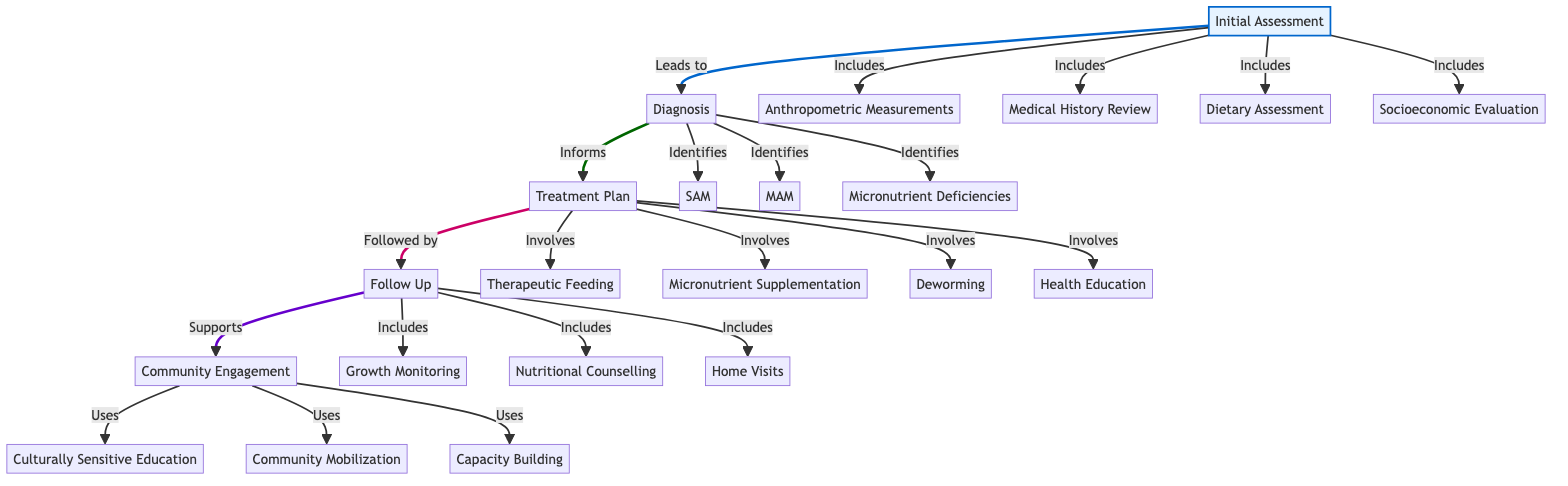What are the components of the Initial Assessment? The diagram lists four components under Initial Assessment: Anthropometric Measurements, Medical History Review, Dietary Assessment, and Socioeconomic Status Evaluation.
Answer: Anthropometric Measurements, Medical History Review, Dietary Assessment, Socioeconomic Status Evaluation How many conditions are identified in the Diagnosis phase? The Diagnosis phase identifies three conditions: Severe Acute Malnutrition (SAM), Moderate Acute Malnutrition (MAM), and Micronutrient Deficiencies, making a total of three conditions.
Answer: Three Which treatment involves Health Education for Caregivers? Health Education for Caregivers is included among the interventions in the Treatment Plan. Following the Treatment Plan leads to this intervention, confirming its place in the pathway.
Answer: Health Education for Caregivers What is the frequency of follow-ups for Moderate Acute Malnutrition? The Follow Up section indicates that follow-ups for Moderate Acute Malnutrition occur monthly. This is identified directly in the corresponding frequency notation in the diagram.
Answer: Monthly What leads to the Community Engagement phase? The Follow Up phase supports the Community Engagement phase, indicating that effective follow-up care contributes to community involvement. This relationship establishes a clear flow between Follow Up and Community Engagement.
Answer: Follow Up What are the strategies used in Community Engagement? The strategies listed for Community Engagement include Culturally Sensitive Nutrition Education, Community Mobilization, and Capacity Building for Local Health Workers, which are specified in the diagram.
Answer: Culturally Sensitive Nutrition Education, Community Mobilization, Capacity Building for Local Health Workers What is the purpose of the Regular Growth Monitoring? The Regular Growth Monitoring is a part of the Follow Up components that aims to track the growth and health of children suffering from malnutrition, ensuring ongoing assessment and care management.
Answer: To track growth and health How do the Initial Assessment and Diagnosis phases connect? The Initial Assessment phase directly leads to the Diagnosis phase in the pathway. This sequential linkage indicates that assessment results inform the diagnosis of malnutrition conditions.
Answer: Leads to What are the therapeutic foods mentioned in the Treatment Plan? The diagram specifies three therapeutic foods: Ready-to-Use Therapeutic Food (RUTF), Fortified Blended Foods (FBF), and Iron-Folic Acid Supplements. These are identified within the Treatment Plan section.
Answer: Ready-to-Use Therapeutic Food, Fortified Blended Foods, Iron-Folic Acid Supplements Which partners are involved in Community Engagement? Partners involved in Community Engagement are Local Community Leaders, Non-Governmental Organizations (NGOs), and International Agencies (e.g., UNICEF, WHO), listed directly in the Community Engagement section.
Answer: Local Community Leaders, Non-Governmental Organizations, International Agencies 